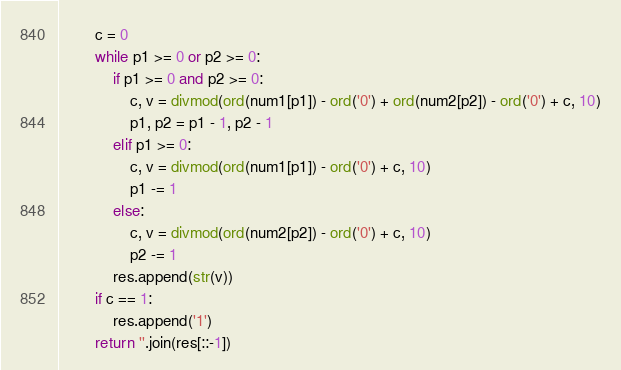Convert code to text. <code><loc_0><loc_0><loc_500><loc_500><_Python_>        c = 0
        while p1 >= 0 or p2 >= 0:
            if p1 >= 0 and p2 >= 0:
                c, v = divmod(ord(num1[p1]) - ord('0') + ord(num2[p2]) - ord('0') + c, 10)
                p1, p2 = p1 - 1, p2 - 1
            elif p1 >= 0:
                c, v = divmod(ord(num1[p1]) - ord('0') + c, 10)
                p1 -= 1
            else:
                c, v = divmod(ord(num2[p2]) - ord('0') + c, 10)
                p2 -= 1
            res.append(str(v))
        if c == 1:
            res.append('1')
        return ''.join(res[::-1])
</code> 